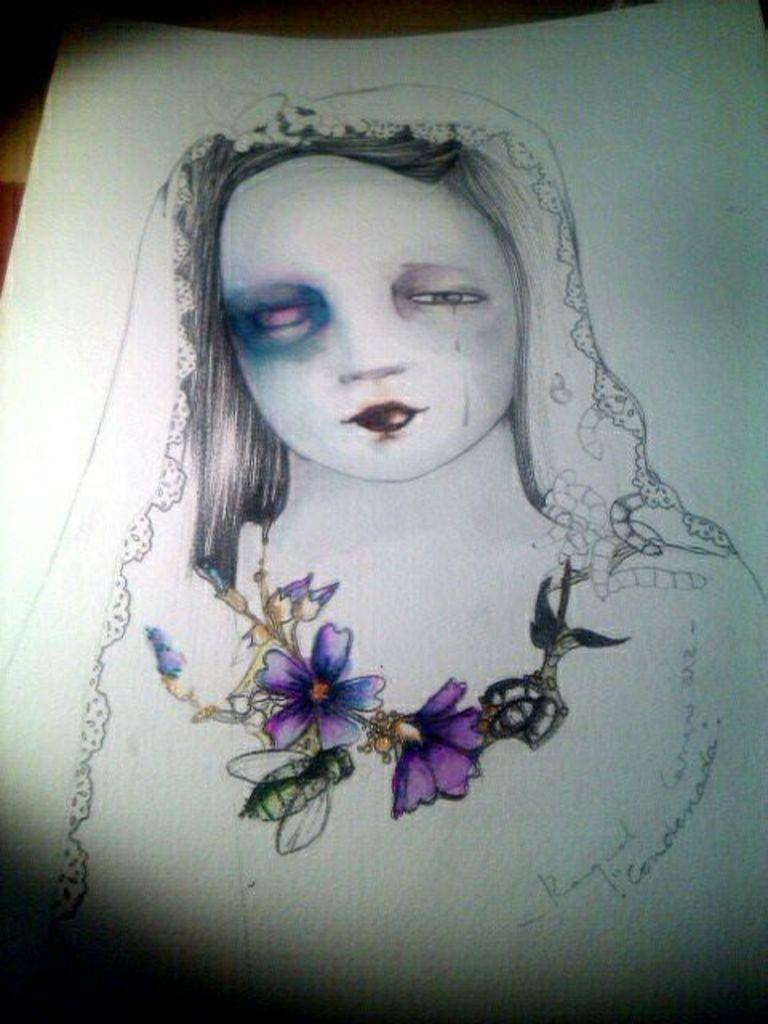What type of artwork is depicted in the image? The image contains a pencil sketch. What subject is the pencil sketch focused on? The pencil sketch is of a woman. What is the background of the pencil sketch? The pencil sketch is on a white paper. How many cherries are depicted in the pencil sketch? There are no cherries present in the pencil sketch; it is a sketch of a woman. What type of calendar is visible in the image? There is no calendar present in the image; it is a pencil sketch of a woman on white paper. 